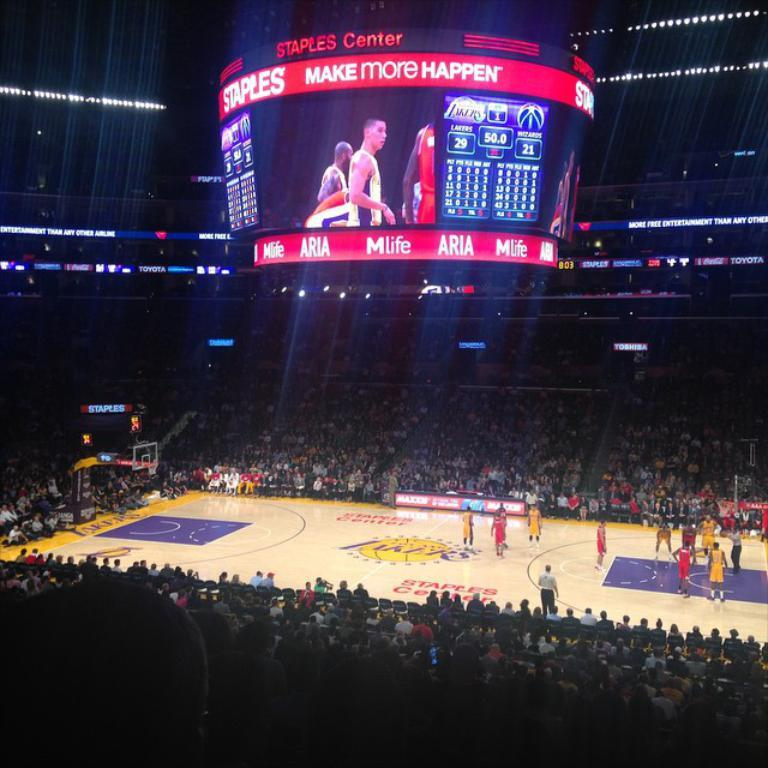<image>
Describe the image concisely. The Lakers are playing at home and are beating the Wizards by 8 points. 